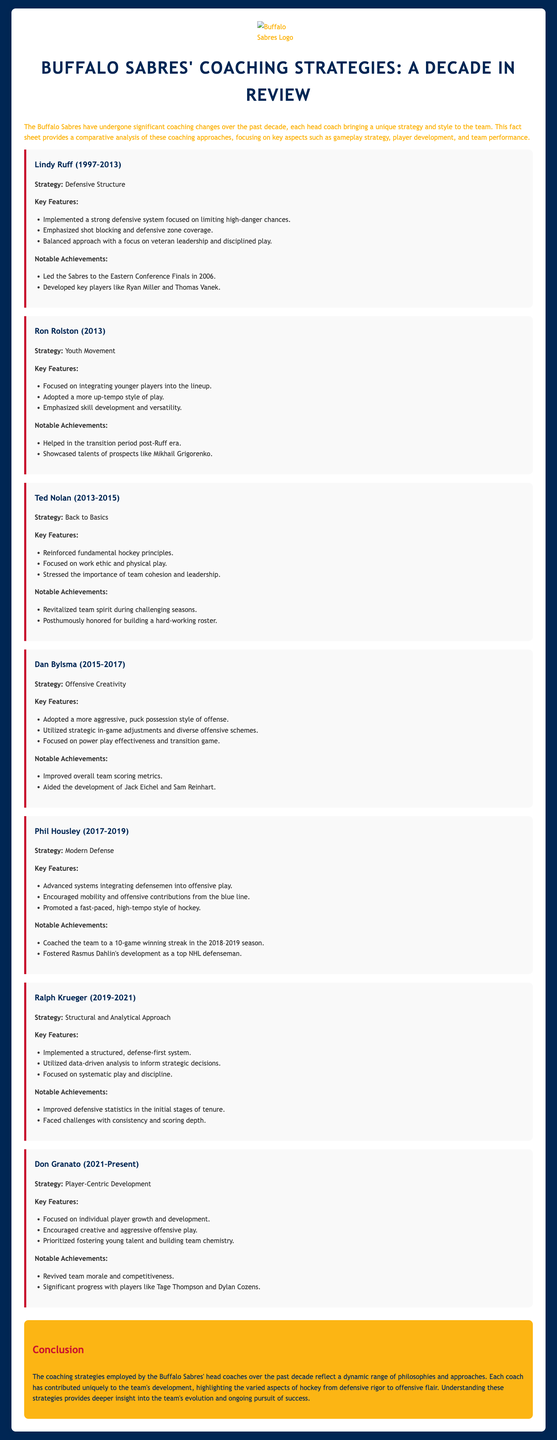What was Lindy Ruff's strategy? Lindy Ruff's strategy defined the approach he took while coaching, which was focused on defensive structure.
Answer: Defensive Structure What notable achievement did Ted Nolan have? The document states that Ted Nolan revitalized team spirit during challenging seasons.
Answer: Revitalized team spirit Who was the head coach during the 2019-2021 season? This question identifies the head coach during that period, which was Ralph Krueger.
Answer: Ralph Krueger What is Don Granato's coaching strategy? This refers to the central concept guiding Don Granato's approach, which is player-centric development.
Answer: Player-Centric Development What year did Phil Housley coach a 10-game winning streak? The specific achievement in the document mentions the 2018-2019 season for Phil Housley.
Answer: 2018–2019 How did Ron Rolston's strategy differ from Lindy Ruff's? This relates to contrasting coaching philosophies; Rolston focused on integrating younger players while Ruff emphasized defense.
Answer: Youth Movement How long did Dan Bylsma coach the Sabres? This question seeks to determine the duration of Dan Bylsma's coaching tenure, which was from 2015 to 2017.
Answer: 2015–2017 What feature did Ralph Krueger emphasize? This refers to a key element of Ralph Krueger's strategy, which was utilizing data-driven analysis.
Answer: Data-driven analysis What aspect did all coaches contribute to? The question looks for a general quality that all coaches aimed to enhance in the team, which was development.
Answer: Development 